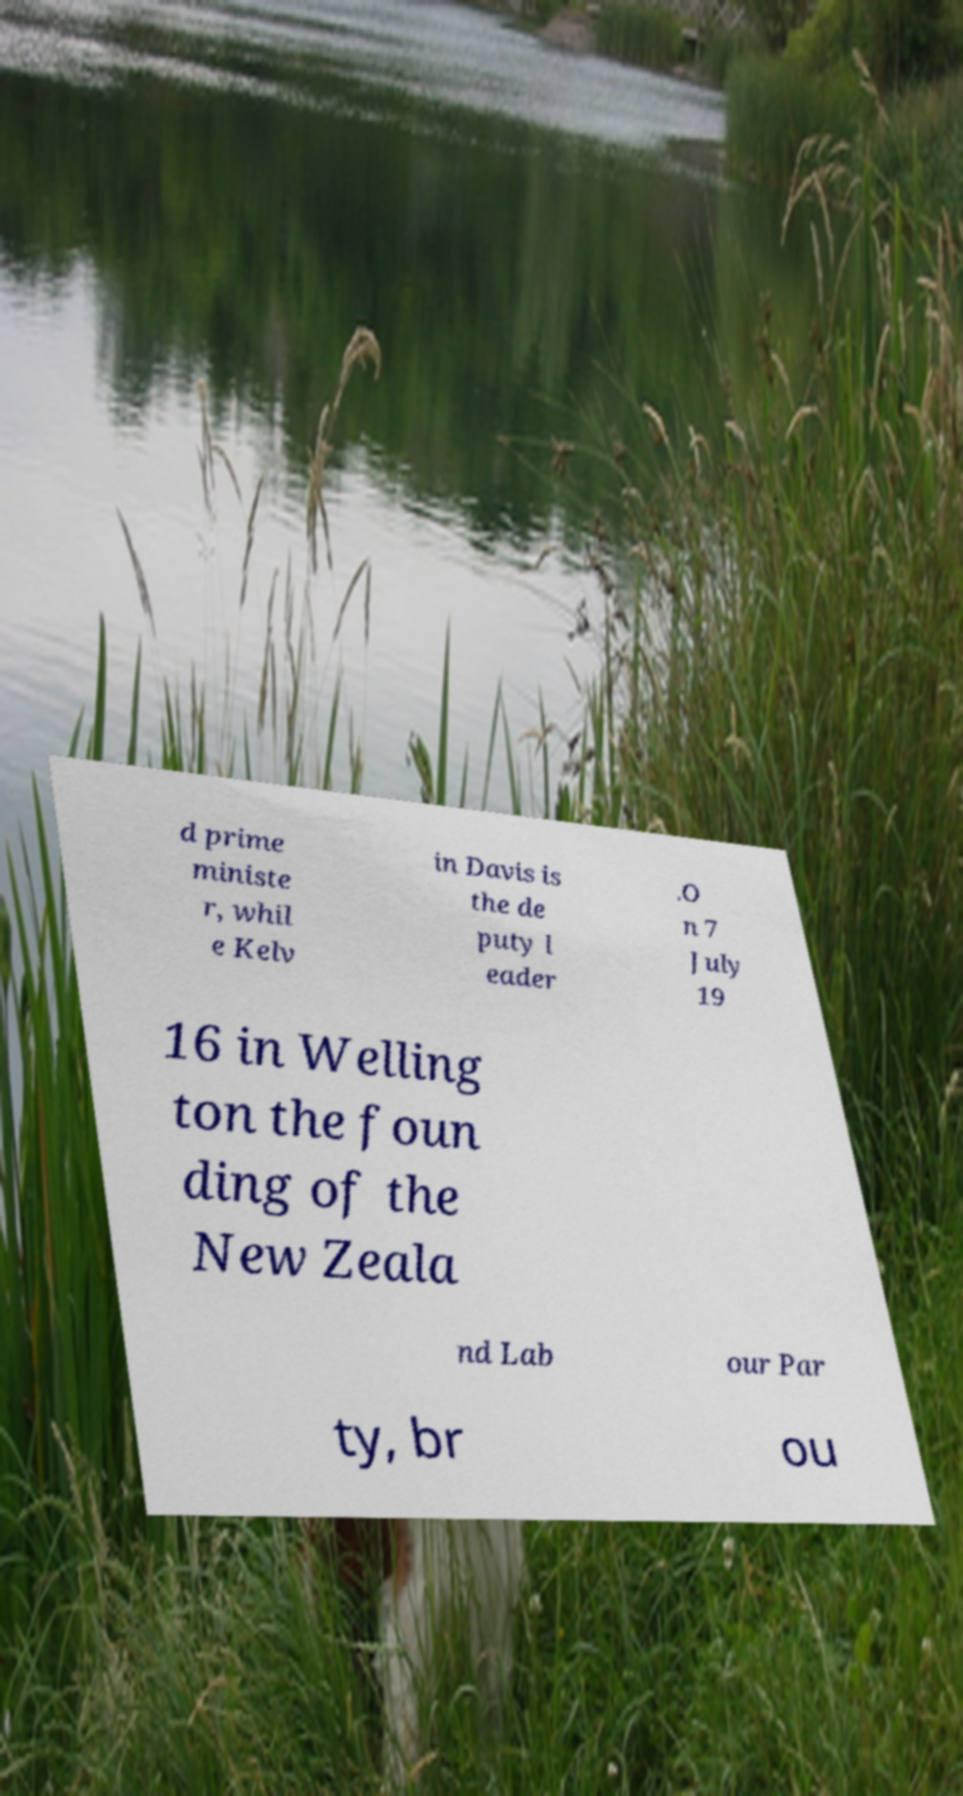Please read and relay the text visible in this image. What does it say? d prime ministe r, whil e Kelv in Davis is the de puty l eader .O n 7 July 19 16 in Welling ton the foun ding of the New Zeala nd Lab our Par ty, br ou 